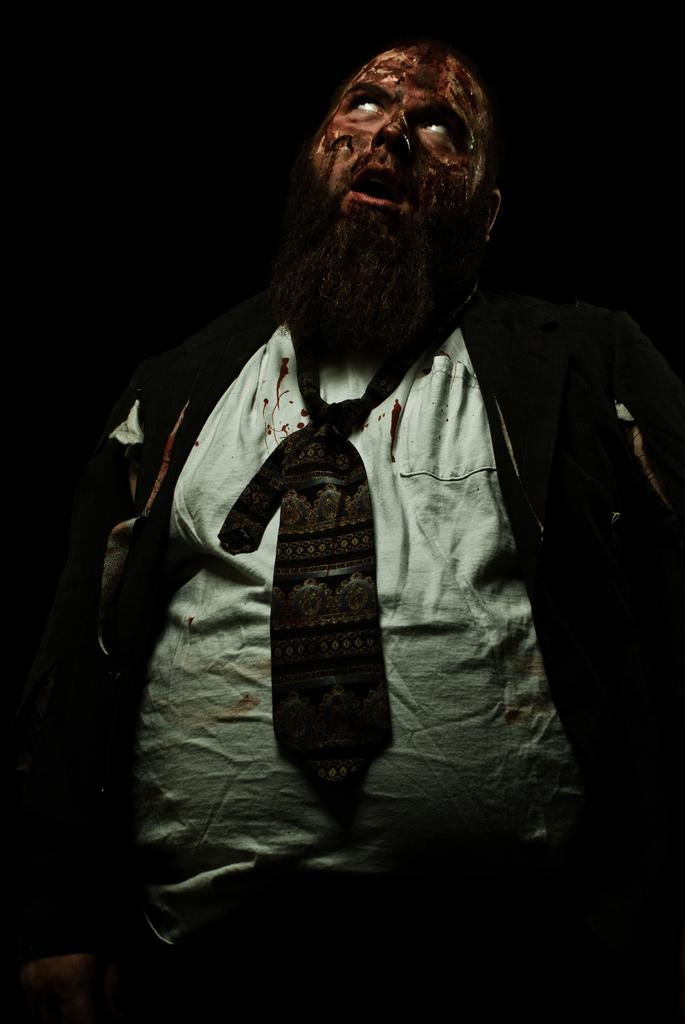What is the main subject of the image? The main subject of the image is a man. What is the man wearing in the image? The man is wearing a suit in the image. What type of tax is being discussed by the man in the image? There is no indication in the image that the man is discussing any type of tax. 